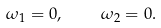Convert formula to latex. <formula><loc_0><loc_0><loc_500><loc_500>\omega _ { 1 } = 0 , \quad \omega _ { 2 } = 0 .</formula> 